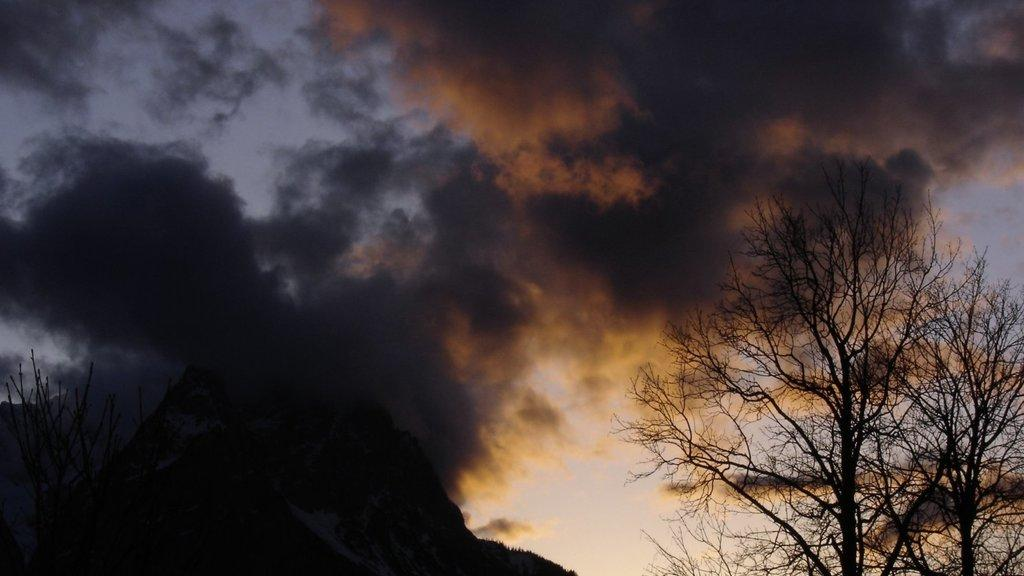What type of vegetation is on the right side of the image? There are trees on the right side of the image. What geographical feature is at the bottom of the image? There is a hill at the bottom of the image. Are there any trees at the bottom of the image? Yes, trees are present at the bottom of the image. What can be seen in the background of the image? There are clouds and the sky visible in the background of the image. What type of pest is crawling on the hill in the image? There is no pest visible in the image; the hill is clear of any such creatures. What topic is being discussed by the trees in the image? Trees do not engage in discussions, so there is no topic being discussed by them in the image. 